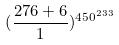<formula> <loc_0><loc_0><loc_500><loc_500>( \frac { 2 7 6 + 6 } { 1 } ) ^ { 4 5 0 ^ { 2 3 3 } }</formula> 